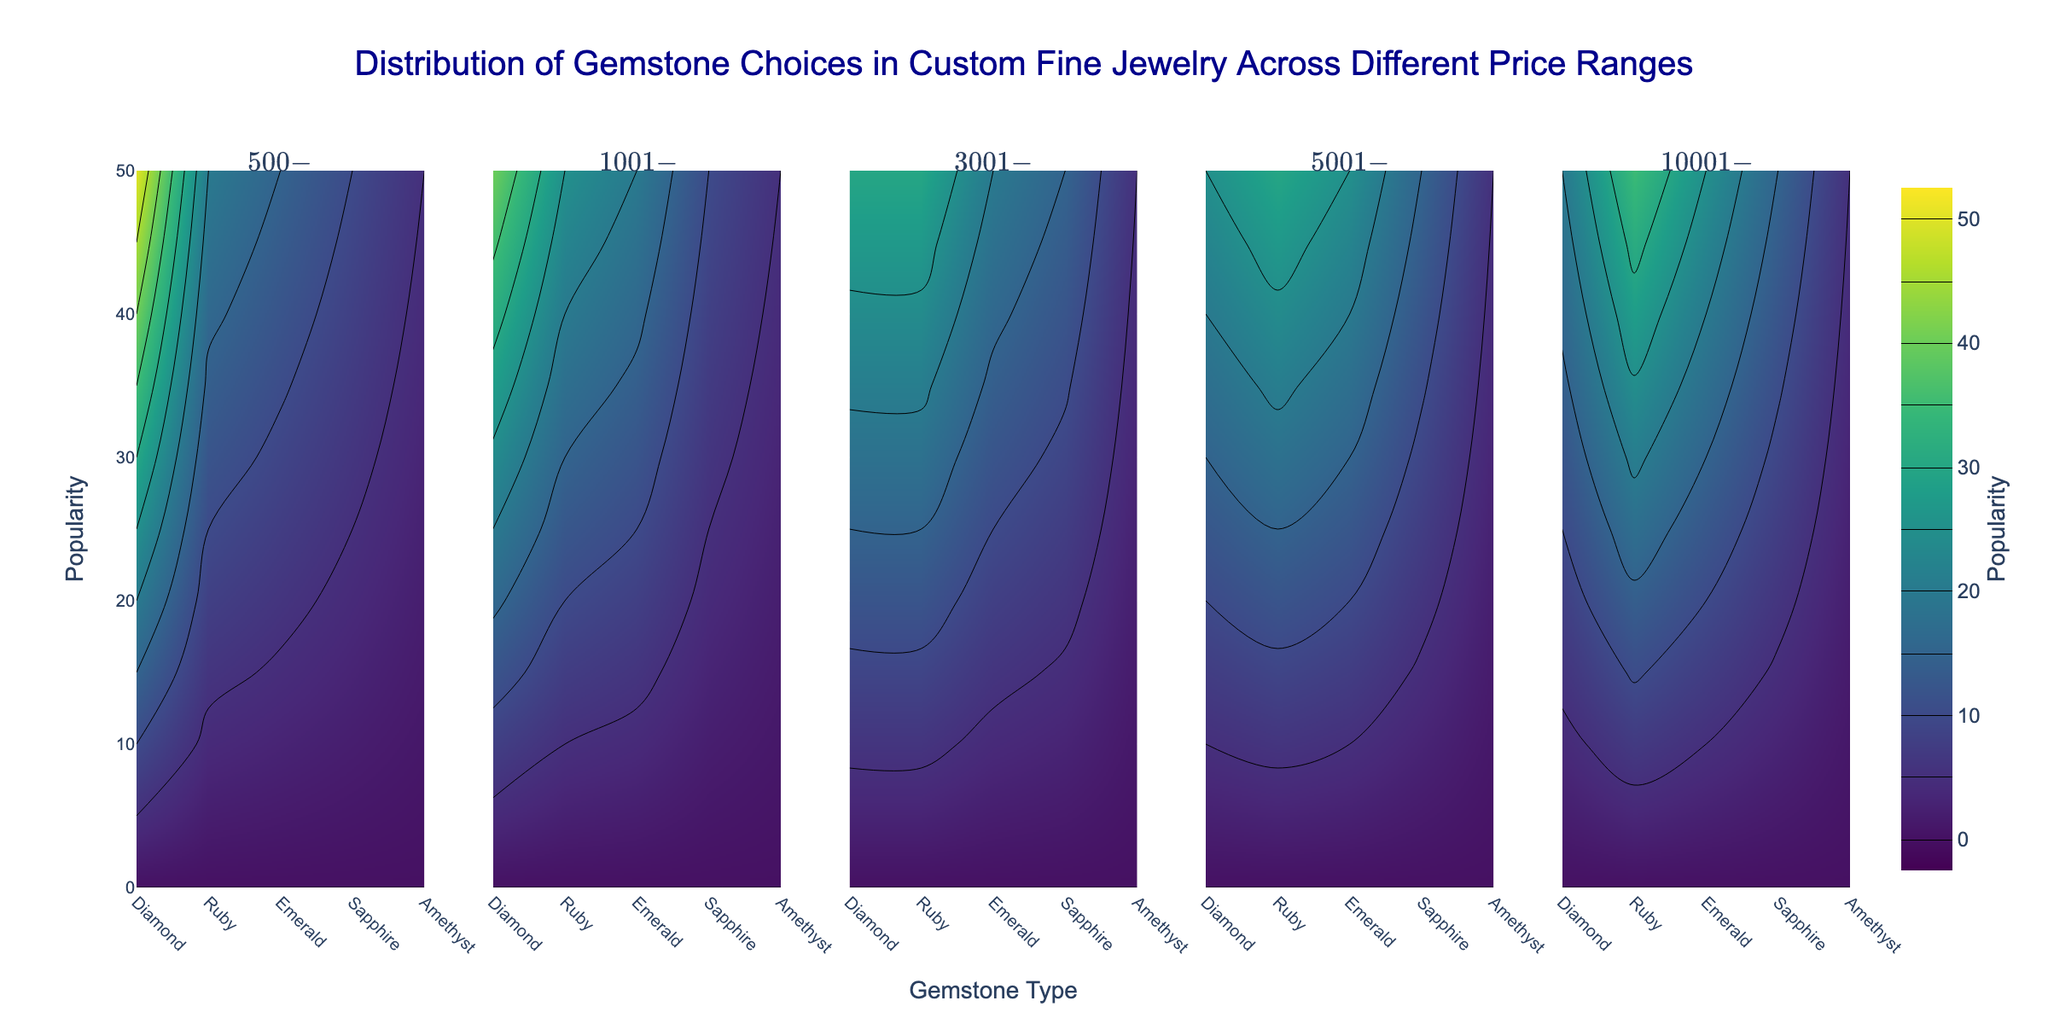What is the title of the figure? The title is located at the top center of the figure and provides a summary of what the data represents.
Answer: Distribution of Gemstone Choices in Custom Fine Jewelry Across Different Price Ranges What does the y-axis represent? The y-axis is labeled with the term that indicates what the vertical axis measures on the contour plots.
Answer: Popularity How many different price ranges are shown in the figure? The figure has multiple subplots, each represented by a different price range in the titles of the subplots.
Answer: 5 Which gemstone type is the most popular in the $500-$1000 price range? Looking at the first subplot, the contour lines are color-coded to reflect popularity, and the darkest color indicates the highest popularity.
Answer: Diamond How does the popularity of Sapphires change as the price range increases from $500-$1000 to $10001-$20000? By comparing the subplots for each price range and observing the color density for Sapphires, we can notice how the color changes across the subplots.
Answer: It remains constant at 15 In which price range does the popularity of Rubies exceed that of Diamonds? Compare the colors and contour levels in each subplot to identify where the color density for Rubies surpasses that of Diamonds.
Answer: $10001-$20000 Which gemstone has the least popularity in all the price ranges? The gemstone with the lightest color consistently across all subplots represents the one with the least popularity.
Answer: Amethyst What is the difference in popularity between Diamonds and Emeralds in the $3001-$5000 price range? In the subplot for $3001-$5000, compare the contour levels for Diamonds and Emeralds, and subtract the popularity of Emeralds from Diamonds.
Answer: 10 Is there any price range where the popularity of all gemstones is roughly similar? By scanning through each subplot, observe the color consistency among all gemstones within a specific price range.
Answer: $3001-$5000 What trend can you observe in the popularity of Diamonds as the price range increases? Analyze the color intensity for Diamonds across all subplots from the cheapest to the most expensive price range.
Answer: It decreases 